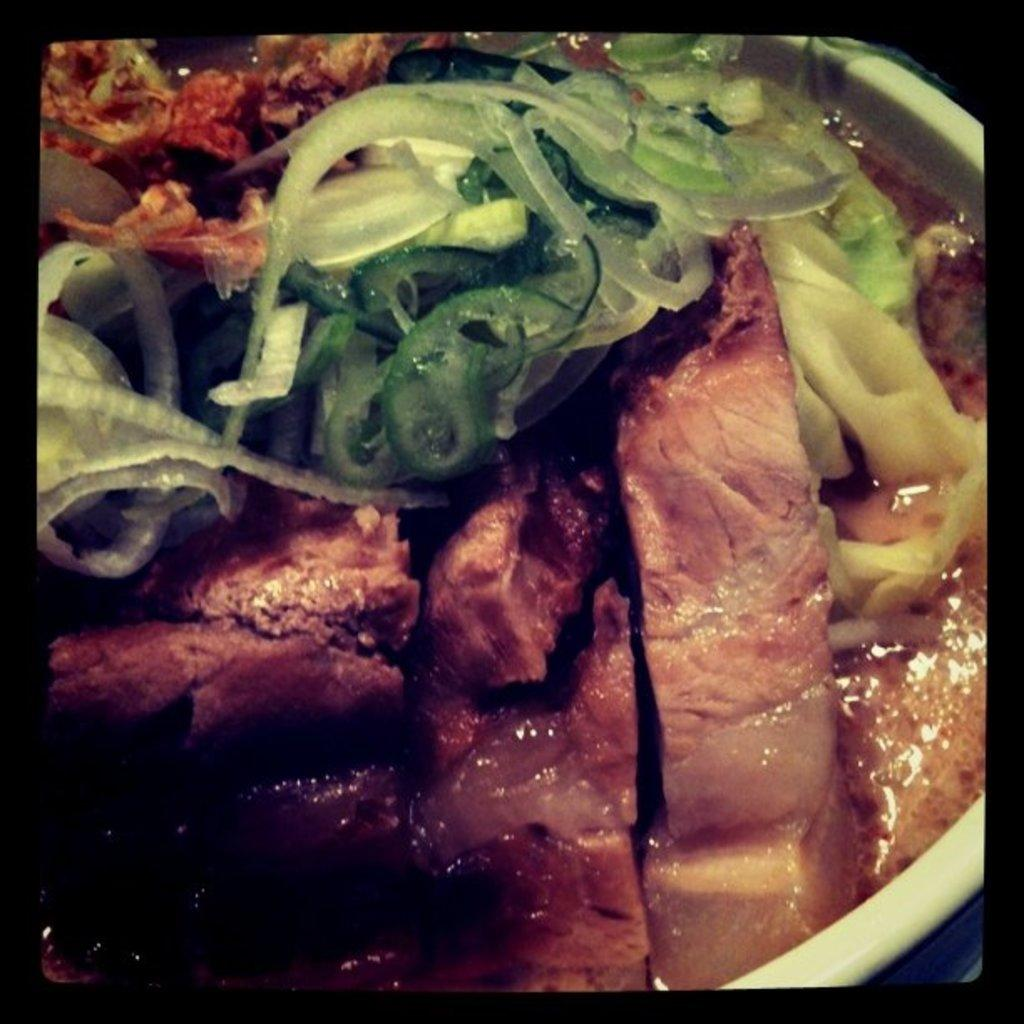What is in the bowl that is visible in the image? There is a bowl with mat slices and vegetables in it. What type of food is in the bowl? The bowl contains mat slices and vegetables. What might someone be about to do with the contents of the bowl? Someone might be about to eat the mat slices and vegetables. Can you describe the setting where the bowl is located? The bowl is located in a setting where it is being used to hold mat slices and vegetables. What color is the pet in the image? There are no pets present in the image. What year is depicted in the image? The image does not depict a specific year; it is a still image of a bowl with mat slices and vegetables in it. 